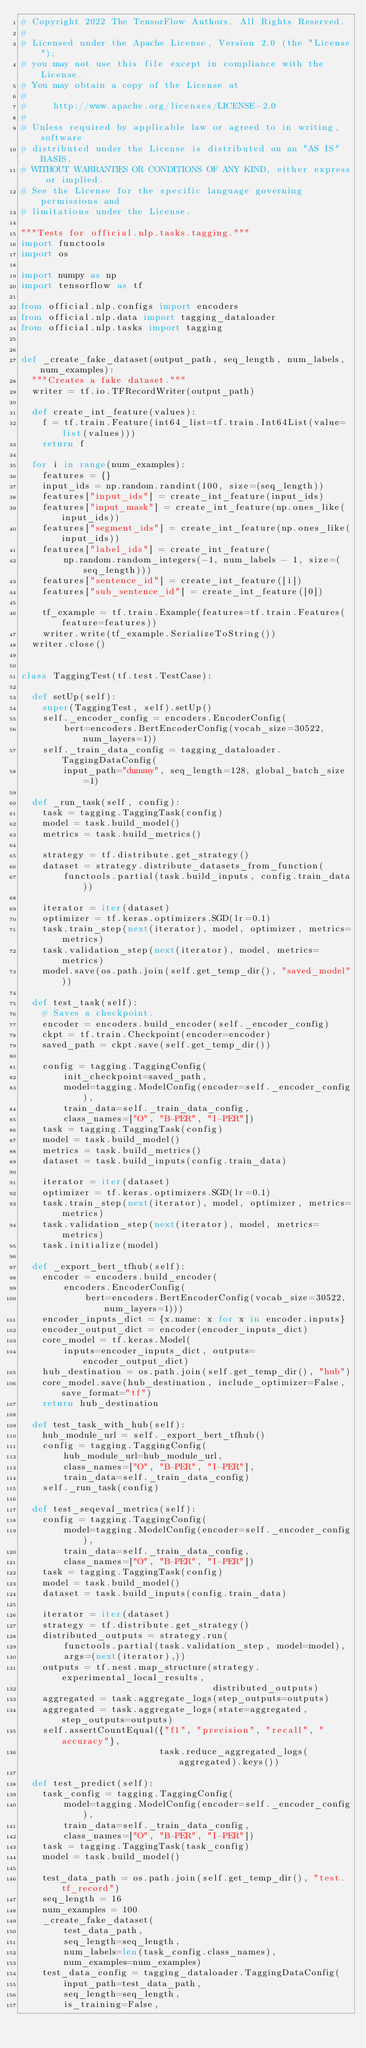<code> <loc_0><loc_0><loc_500><loc_500><_Python_># Copyright 2022 The TensorFlow Authors. All Rights Reserved.
#
# Licensed under the Apache License, Version 2.0 (the "License");
# you may not use this file except in compliance with the License.
# You may obtain a copy of the License at
#
#     http://www.apache.org/licenses/LICENSE-2.0
#
# Unless required by applicable law or agreed to in writing, software
# distributed under the License is distributed on an "AS IS" BASIS,
# WITHOUT WARRANTIES OR CONDITIONS OF ANY KIND, either express or implied.
# See the License for the specific language governing permissions and
# limitations under the License.

"""Tests for official.nlp.tasks.tagging."""
import functools
import os

import numpy as np
import tensorflow as tf

from official.nlp.configs import encoders
from official.nlp.data import tagging_dataloader
from official.nlp.tasks import tagging


def _create_fake_dataset(output_path, seq_length, num_labels, num_examples):
  """Creates a fake dataset."""
  writer = tf.io.TFRecordWriter(output_path)

  def create_int_feature(values):
    f = tf.train.Feature(int64_list=tf.train.Int64List(value=list(values)))
    return f

  for i in range(num_examples):
    features = {}
    input_ids = np.random.randint(100, size=(seq_length))
    features["input_ids"] = create_int_feature(input_ids)
    features["input_mask"] = create_int_feature(np.ones_like(input_ids))
    features["segment_ids"] = create_int_feature(np.ones_like(input_ids))
    features["label_ids"] = create_int_feature(
        np.random.random_integers(-1, num_labels - 1, size=(seq_length)))
    features["sentence_id"] = create_int_feature([i])
    features["sub_sentence_id"] = create_int_feature([0])

    tf_example = tf.train.Example(features=tf.train.Features(feature=features))
    writer.write(tf_example.SerializeToString())
  writer.close()


class TaggingTest(tf.test.TestCase):

  def setUp(self):
    super(TaggingTest, self).setUp()
    self._encoder_config = encoders.EncoderConfig(
        bert=encoders.BertEncoderConfig(vocab_size=30522, num_layers=1))
    self._train_data_config = tagging_dataloader.TaggingDataConfig(
        input_path="dummy", seq_length=128, global_batch_size=1)

  def _run_task(self, config):
    task = tagging.TaggingTask(config)
    model = task.build_model()
    metrics = task.build_metrics()

    strategy = tf.distribute.get_strategy()
    dataset = strategy.distribute_datasets_from_function(
        functools.partial(task.build_inputs, config.train_data))

    iterator = iter(dataset)
    optimizer = tf.keras.optimizers.SGD(lr=0.1)
    task.train_step(next(iterator), model, optimizer, metrics=metrics)
    task.validation_step(next(iterator), model, metrics=metrics)
    model.save(os.path.join(self.get_temp_dir(), "saved_model"))

  def test_task(self):
    # Saves a checkpoint.
    encoder = encoders.build_encoder(self._encoder_config)
    ckpt = tf.train.Checkpoint(encoder=encoder)
    saved_path = ckpt.save(self.get_temp_dir())

    config = tagging.TaggingConfig(
        init_checkpoint=saved_path,
        model=tagging.ModelConfig(encoder=self._encoder_config),
        train_data=self._train_data_config,
        class_names=["O", "B-PER", "I-PER"])
    task = tagging.TaggingTask(config)
    model = task.build_model()
    metrics = task.build_metrics()
    dataset = task.build_inputs(config.train_data)

    iterator = iter(dataset)
    optimizer = tf.keras.optimizers.SGD(lr=0.1)
    task.train_step(next(iterator), model, optimizer, metrics=metrics)
    task.validation_step(next(iterator), model, metrics=metrics)
    task.initialize(model)

  def _export_bert_tfhub(self):
    encoder = encoders.build_encoder(
        encoders.EncoderConfig(
            bert=encoders.BertEncoderConfig(vocab_size=30522, num_layers=1)))
    encoder_inputs_dict = {x.name: x for x in encoder.inputs}
    encoder_output_dict = encoder(encoder_inputs_dict)
    core_model = tf.keras.Model(
        inputs=encoder_inputs_dict, outputs=encoder_output_dict)
    hub_destination = os.path.join(self.get_temp_dir(), "hub")
    core_model.save(hub_destination, include_optimizer=False, save_format="tf")
    return hub_destination

  def test_task_with_hub(self):
    hub_module_url = self._export_bert_tfhub()
    config = tagging.TaggingConfig(
        hub_module_url=hub_module_url,
        class_names=["O", "B-PER", "I-PER"],
        train_data=self._train_data_config)
    self._run_task(config)

  def test_seqeval_metrics(self):
    config = tagging.TaggingConfig(
        model=tagging.ModelConfig(encoder=self._encoder_config),
        train_data=self._train_data_config,
        class_names=["O", "B-PER", "I-PER"])
    task = tagging.TaggingTask(config)
    model = task.build_model()
    dataset = task.build_inputs(config.train_data)

    iterator = iter(dataset)
    strategy = tf.distribute.get_strategy()
    distributed_outputs = strategy.run(
        functools.partial(task.validation_step, model=model),
        args=(next(iterator),))
    outputs = tf.nest.map_structure(strategy.experimental_local_results,
                                    distributed_outputs)
    aggregated = task.aggregate_logs(step_outputs=outputs)
    aggregated = task.aggregate_logs(state=aggregated, step_outputs=outputs)
    self.assertCountEqual({"f1", "precision", "recall", "accuracy"},
                          task.reduce_aggregated_logs(aggregated).keys())

  def test_predict(self):
    task_config = tagging.TaggingConfig(
        model=tagging.ModelConfig(encoder=self._encoder_config),
        train_data=self._train_data_config,
        class_names=["O", "B-PER", "I-PER"])
    task = tagging.TaggingTask(task_config)
    model = task.build_model()

    test_data_path = os.path.join(self.get_temp_dir(), "test.tf_record")
    seq_length = 16
    num_examples = 100
    _create_fake_dataset(
        test_data_path,
        seq_length=seq_length,
        num_labels=len(task_config.class_names),
        num_examples=num_examples)
    test_data_config = tagging_dataloader.TaggingDataConfig(
        input_path=test_data_path,
        seq_length=seq_length,
        is_training=False,</code> 